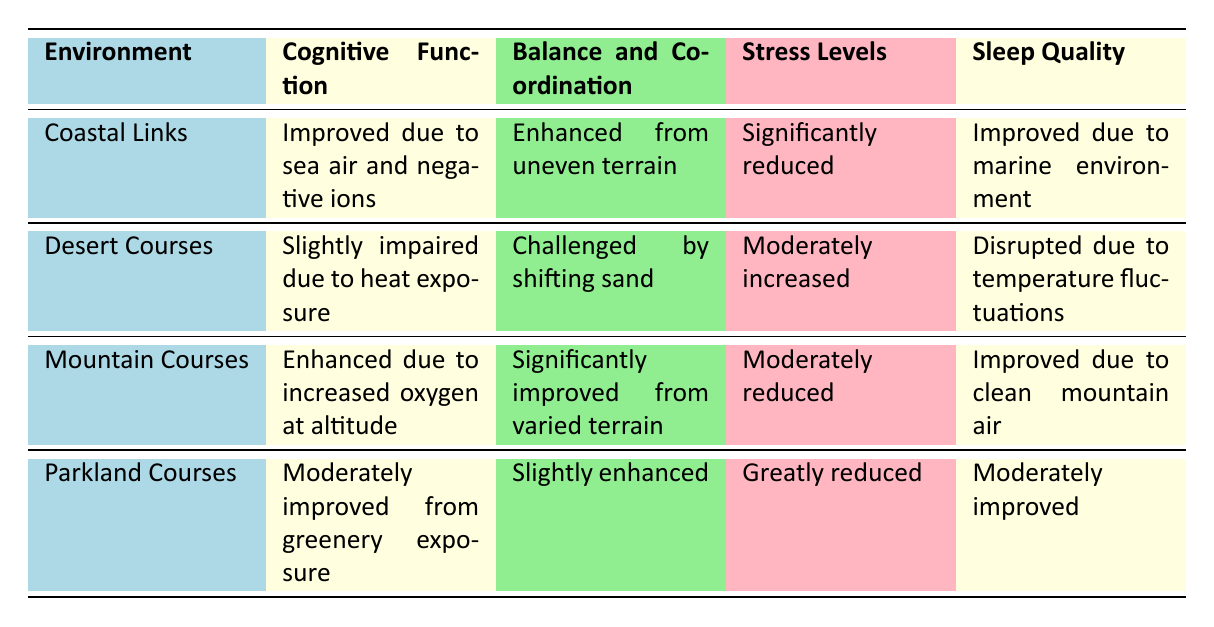What are the neurological effects on cognitive function in Coastal Links? The table indicates that in Coastal Links, cognitive function is "Improved due to sea air and negative ions."
Answer: Improved due to sea air and negative ions Which course environment has the greatest reduction in stress levels? From the table, the Parkland Courses have "Greatly reduced" stress levels, while Coastal Links mention "Significantly reduced." Therefore, it is Parkland Courses.
Answer: Parkland Courses Is sleep quality improved in Mountain Courses? The table states that in Mountain Courses, sleep quality is "Improved due to clean mountain air." Therefore, yes, sleep quality is improved.
Answer: Yes How does balance and coordination in Desert Courses compare to Coastal Links? The balance and coordination in Desert Courses is "Challenged by shifting sand," while in Coastal Links, it is "Enhanced from uneven terrain." This indicates that Coastal Links has better balance and coordination than Desert Courses.
Answer: Coastal Links has better balance and coordination than Desert Courses What is the difference in cognitive function between Mountain Courses and Parkland Courses? Mountain Courses show "Enhanced due to increased oxygen at altitude," whereas Parkland Courses indicate "Moderately improved from greenery exposure." This suggests that Mountain Courses have a greater enhancement compared to Parkland Courses.
Answer: Mountain Courses have a greater enhancement Which environment leads to slightly impaired cognitive function? The table specifies that Desert Courses experience "Slightly impaired due to heat exposure."
Answer: Desert Courses Which environment has the highest stress levels? From the stress levels listed, Desert Courses have "Moderately increased," while the others have "Significantly reduced" or "Greatly reduced." Therefore, Desert Courses have the highest stress levels.
Answer: Desert Courses Do Coastal Links improve sensory processing? Yes, the table shows that Coastal Links have "Heightened awareness from wind and sound," indicating an improvement in sensory processing.
Answer: Yes How many golf course environments show improved sleep quality? Upon reviewing the table, Coastal Links, Mountain Courses, and Parkland Courses each indicate improved sleep quality. Therefore, there are three environments that show improvement.
Answer: Three environments show improvement 